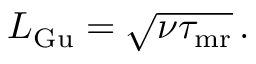Convert formula to latex. <formula><loc_0><loc_0><loc_500><loc_500>\begin{array} { r } { L _ { G u } = \sqrt { { \nu } \tau _ { m r } } \, . } \end{array}</formula> 